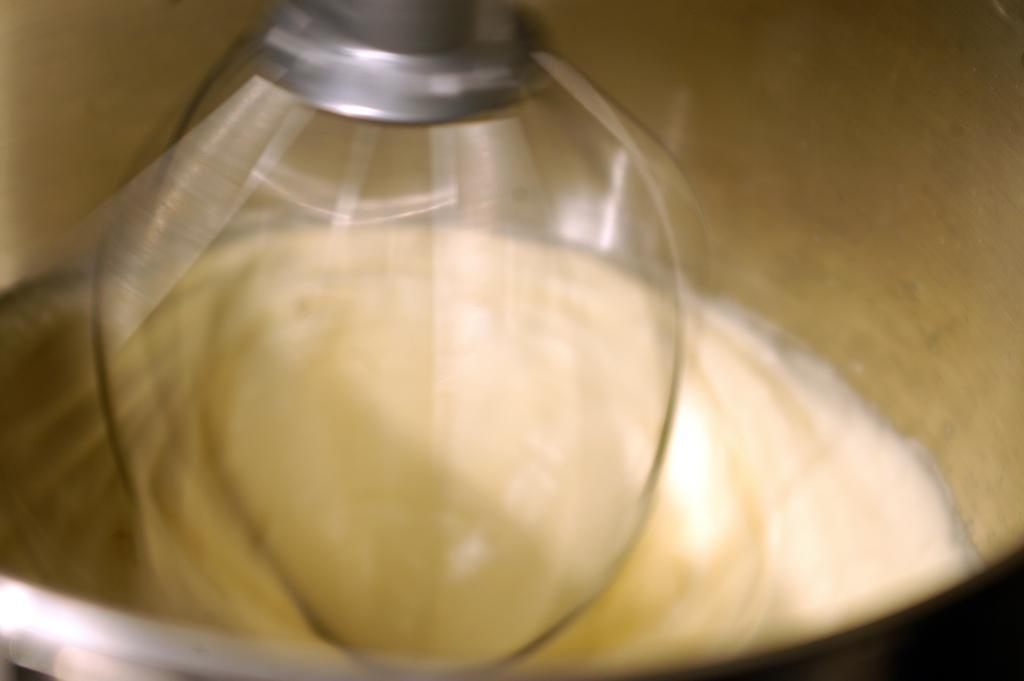Could you give a brief overview of what you see in this image? In this image we can see the battery in the bowl. We can also see the stirrer. 